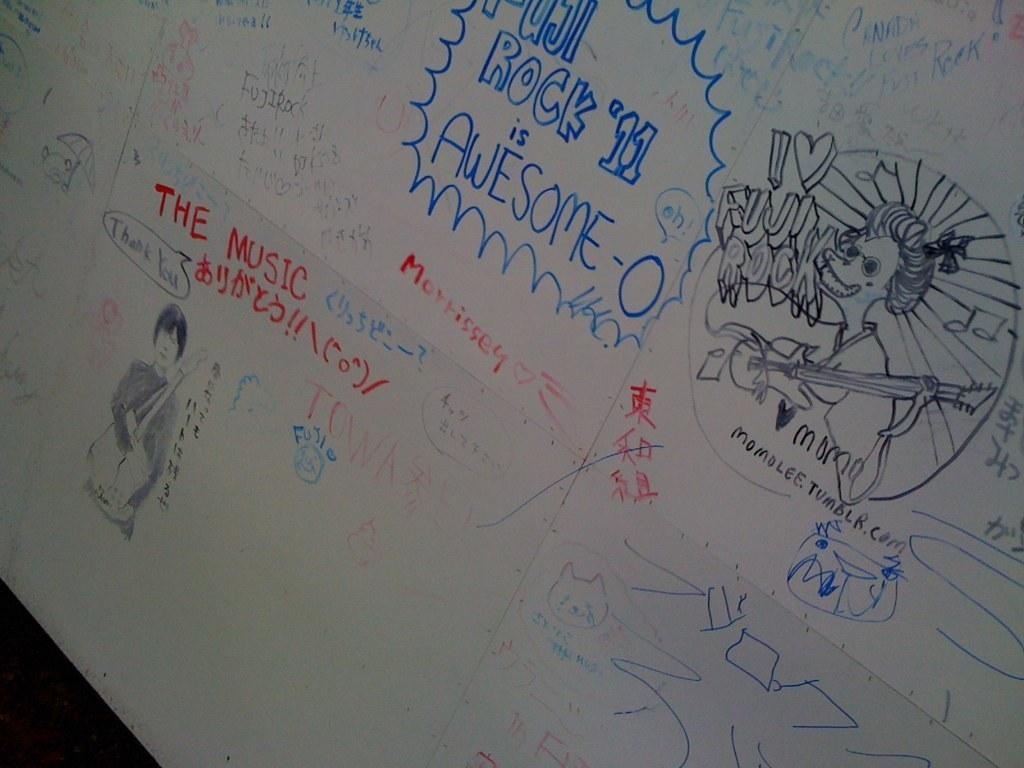<image>
Give a short and clear explanation of the subsequent image. A whiteboard with drawings which includes an awesome-o writing. 